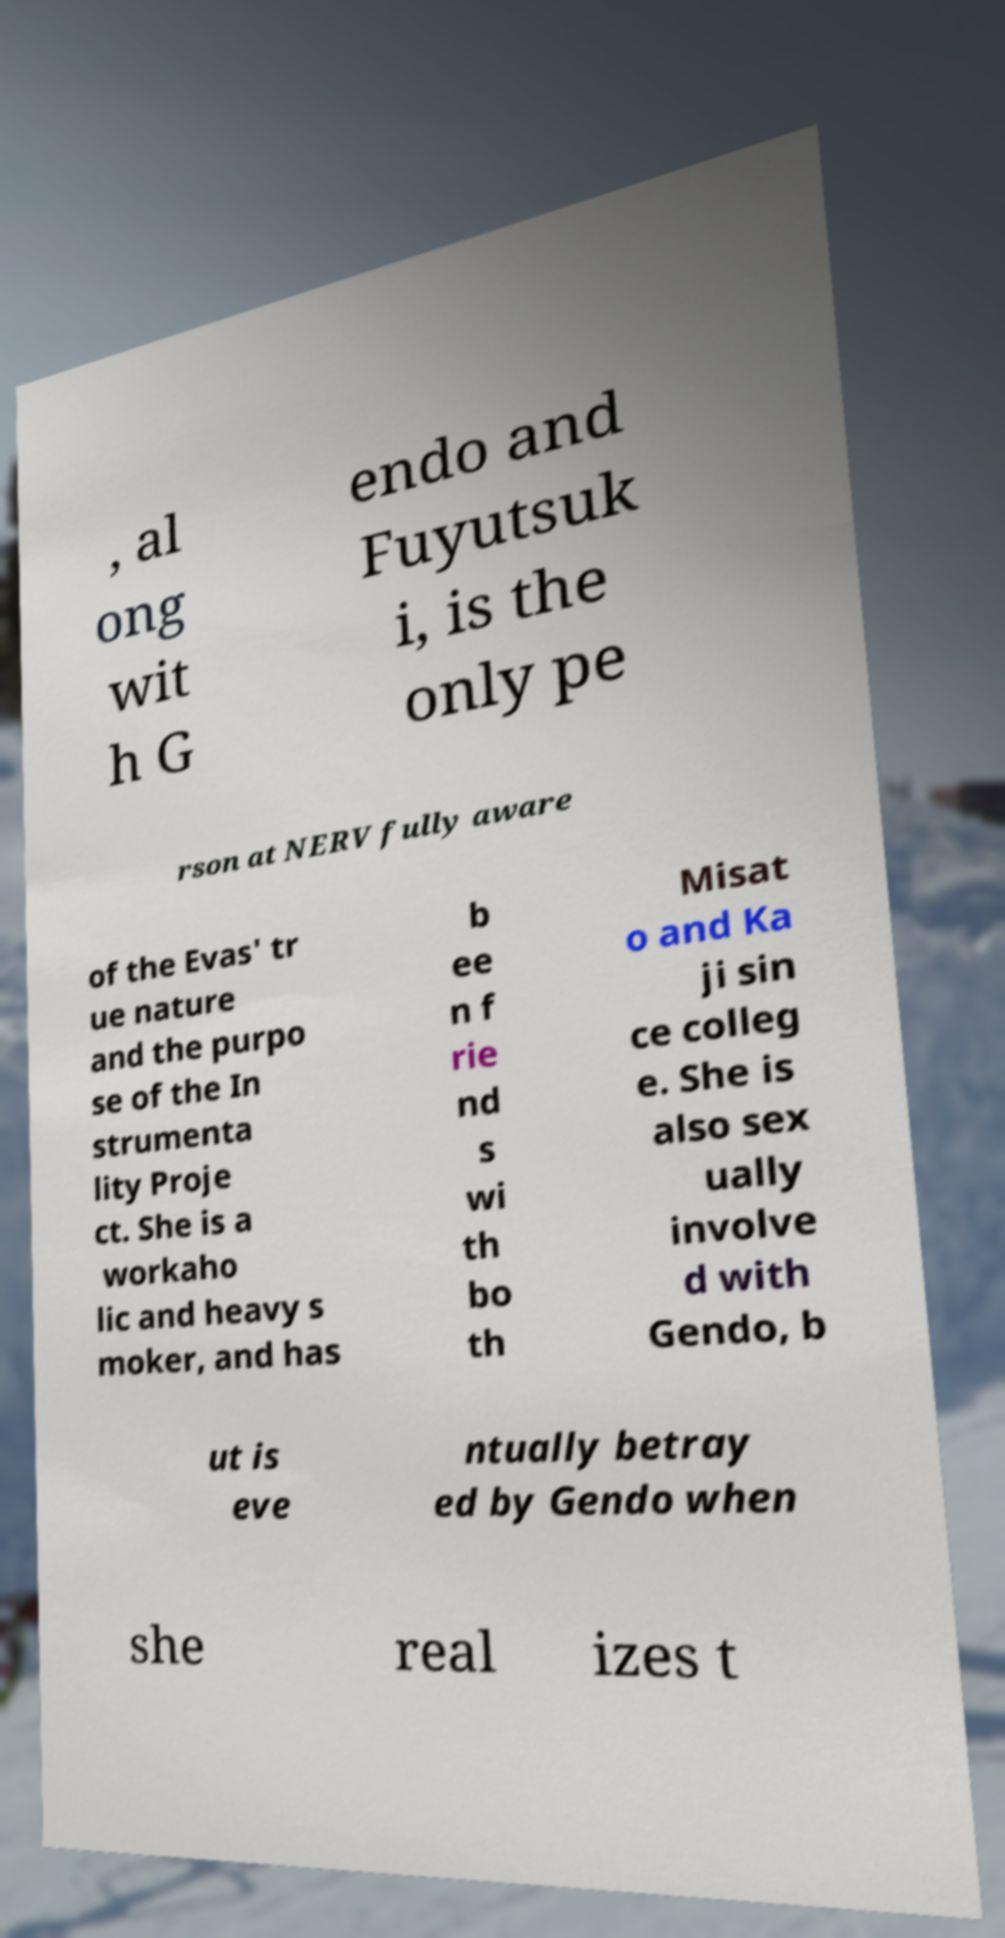Can you accurately transcribe the text from the provided image for me? , al ong wit h G endo and Fuyutsuk i, is the only pe rson at NERV fully aware of the Evas' tr ue nature and the purpo se of the In strumenta lity Proje ct. She is a workaho lic and heavy s moker, and has b ee n f rie nd s wi th bo th Misat o and Ka ji sin ce colleg e. She is also sex ually involve d with Gendo, b ut is eve ntually betray ed by Gendo when she real izes t 